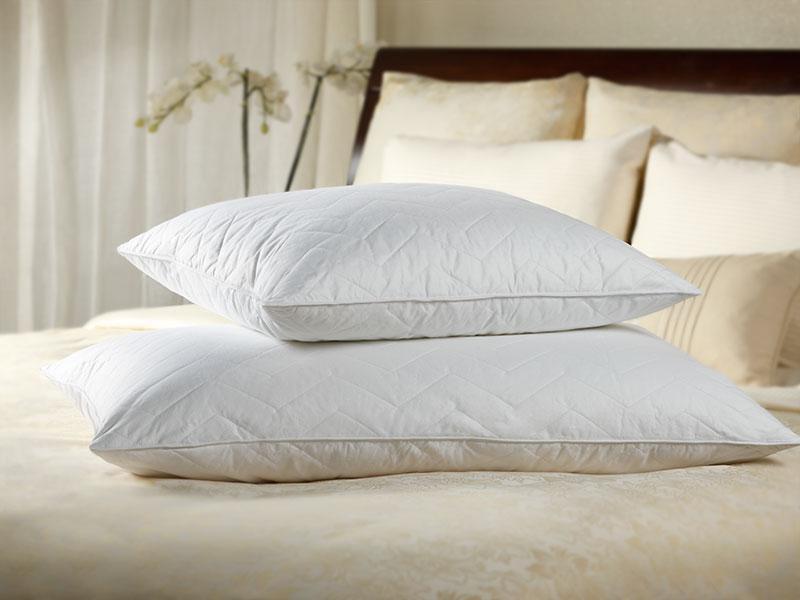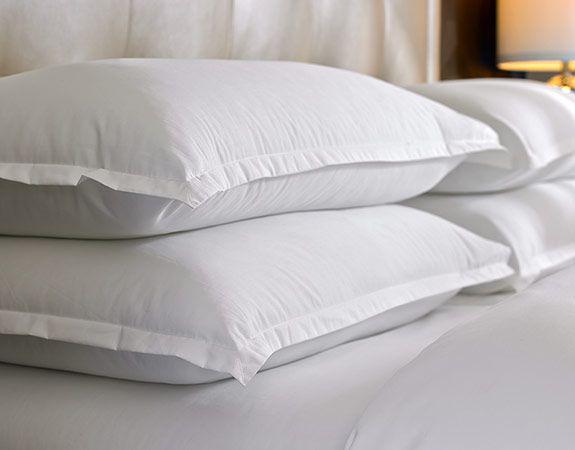The first image is the image on the left, the second image is the image on the right. For the images shown, is this caption "The right image contains exactly three white pillows with smooth surfaces arranged overlapping but not stacked vertically." true? Answer yes or no. No. 